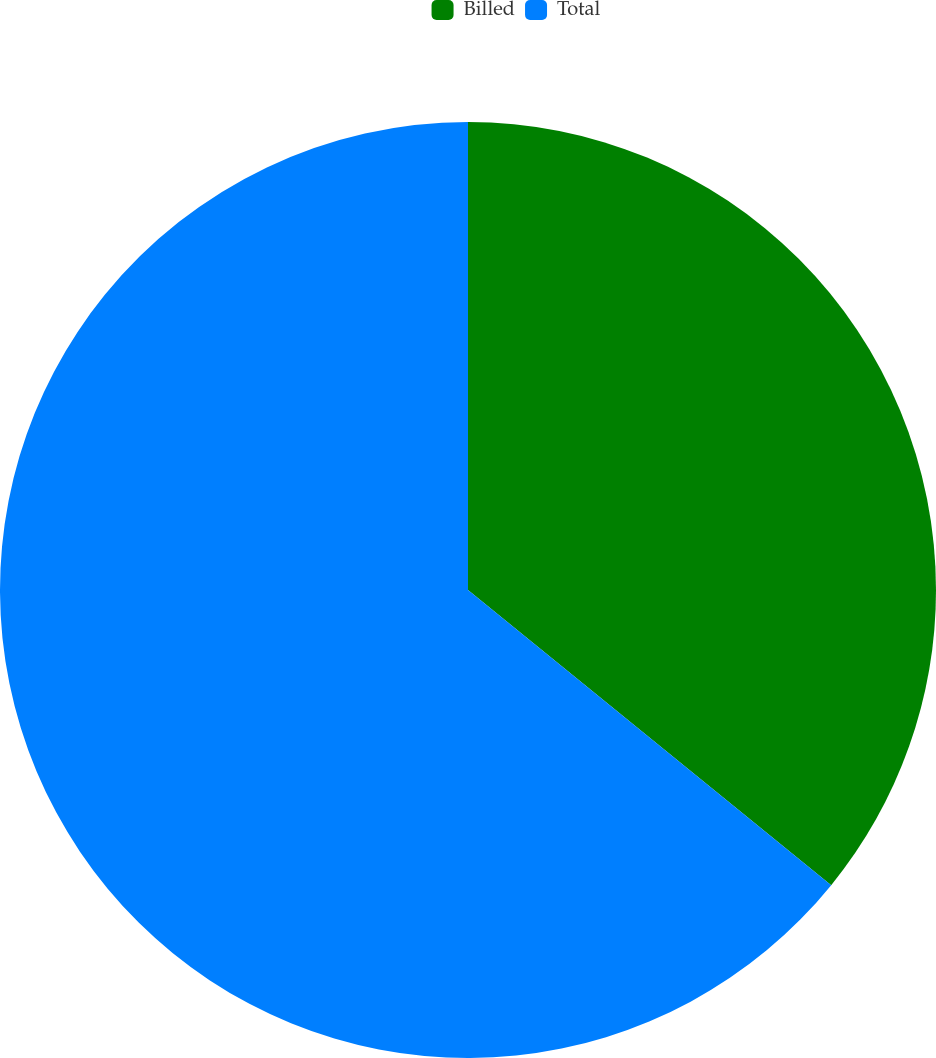Convert chart. <chart><loc_0><loc_0><loc_500><loc_500><pie_chart><fcel>Billed<fcel>Total<nl><fcel>35.86%<fcel>64.14%<nl></chart> 